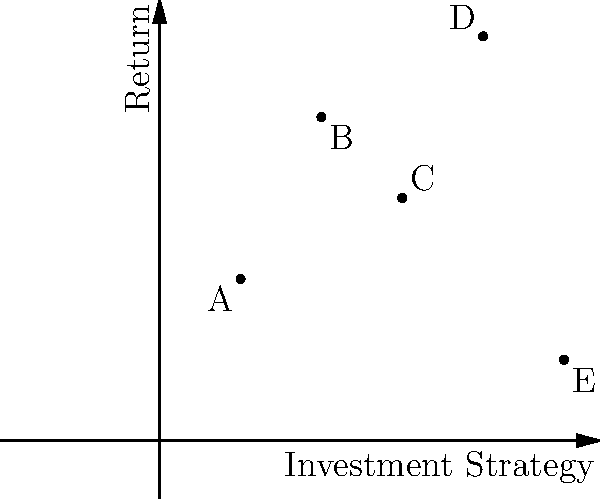Consider a group $G$ acting on a set of investment strategies represented by points A, B, C, D, and E in the graph. If the group action preserves the relative ordering of returns, how many distinct orbits are there under this group action? To solve this problem, we need to follow these steps:

1) First, understand what the group action preserves:
   The action preserves the relative ordering of returns. This means that if strategy X has a higher return than strategy Y, this relationship must be maintained under any group element's action.

2) Analyze the relative ordering of returns:
   From the graph, we can see that D > B > C > A > E in terms of returns.

3) Consider possible orbits:
   An orbit is a set of elements that can be transformed into each other by the group action. Given that the relative ordering must be preserved, we can deduce:

   - D cannot be in the same orbit as any other point, as it has the highest return.
   - E cannot be in the same orbit as any other point, as it has the lowest return.
   - B, C, and A could potentially be in the same orbit, as their relative positions could be swapped while still maintaining B > C > A.

4) Count the distinct orbits:
   - Orbit 1: {D}
   - Orbit 2: {B, C, A} (potentially)
   - Orbit 3: {E}

Therefore, there are 3 distinct orbits under this group action.
Answer: 3 orbits 